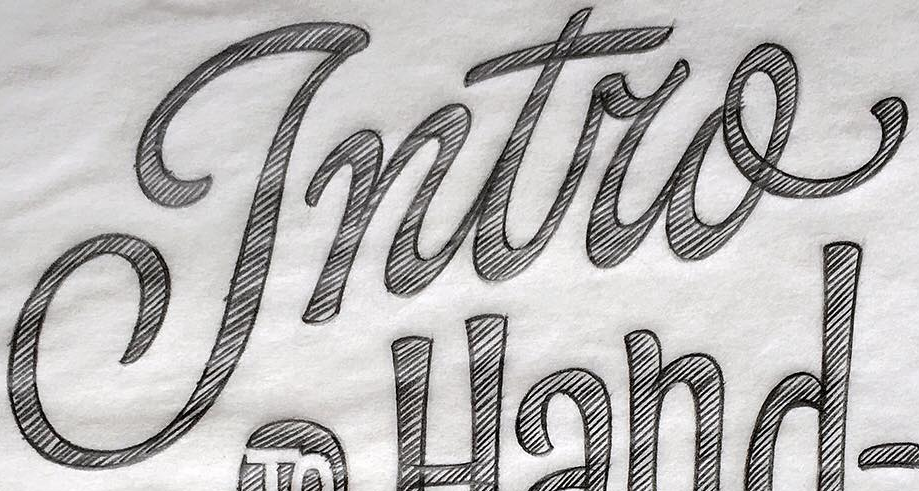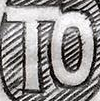What text appears in these images from left to right, separated by a semicolon? Intro; TO 